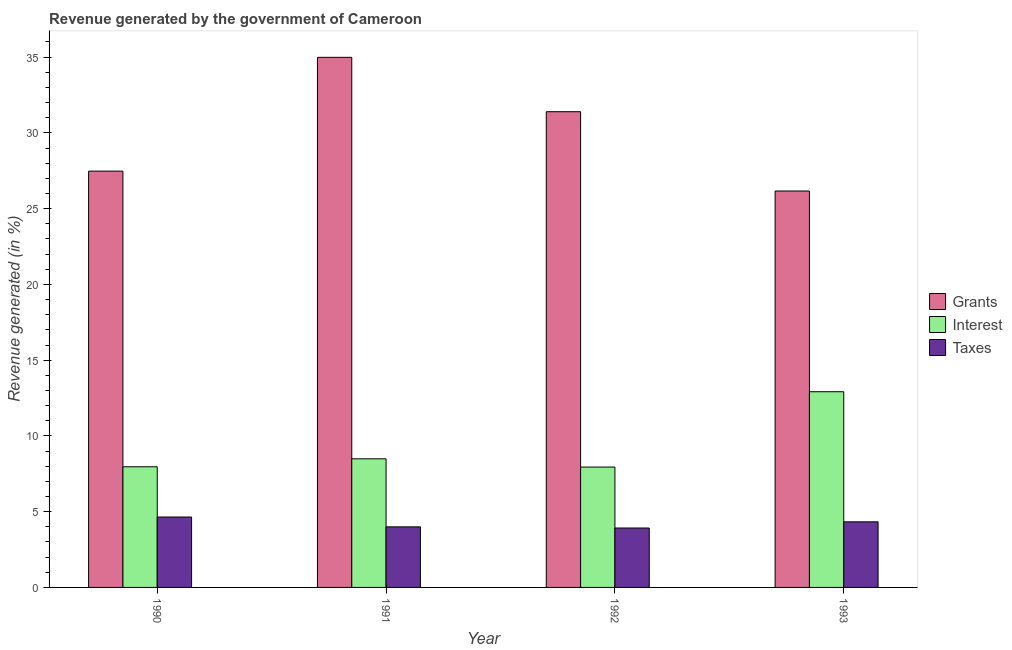Are the number of bars per tick equal to the number of legend labels?
Your answer should be compact. Yes. Are the number of bars on each tick of the X-axis equal?
Provide a succinct answer. Yes. What is the percentage of revenue generated by grants in 1993?
Provide a short and direct response. 26.16. Across all years, what is the maximum percentage of revenue generated by interest?
Your response must be concise. 12.92. Across all years, what is the minimum percentage of revenue generated by interest?
Give a very brief answer. 7.94. In which year was the percentage of revenue generated by grants maximum?
Offer a very short reply. 1991. In which year was the percentage of revenue generated by grants minimum?
Your answer should be very brief. 1993. What is the total percentage of revenue generated by grants in the graph?
Offer a very short reply. 120.02. What is the difference between the percentage of revenue generated by interest in 1991 and that in 1992?
Ensure brevity in your answer.  0.54. What is the difference between the percentage of revenue generated by grants in 1993 and the percentage of revenue generated by taxes in 1991?
Give a very brief answer. -8.82. What is the average percentage of revenue generated by grants per year?
Provide a succinct answer. 30.01. In the year 1993, what is the difference between the percentage of revenue generated by taxes and percentage of revenue generated by interest?
Ensure brevity in your answer.  0. In how many years, is the percentage of revenue generated by interest greater than 22 %?
Give a very brief answer. 0. What is the ratio of the percentage of revenue generated by grants in 1990 to that in 1992?
Give a very brief answer. 0.88. Is the percentage of revenue generated by interest in 1990 less than that in 1992?
Provide a succinct answer. No. Is the difference between the percentage of revenue generated by interest in 1990 and 1993 greater than the difference between the percentage of revenue generated by grants in 1990 and 1993?
Your answer should be compact. No. What is the difference between the highest and the second highest percentage of revenue generated by taxes?
Provide a succinct answer. 0.32. What is the difference between the highest and the lowest percentage of revenue generated by grants?
Your answer should be compact. 8.82. In how many years, is the percentage of revenue generated by taxes greater than the average percentage of revenue generated by taxes taken over all years?
Offer a terse response. 2. Is the sum of the percentage of revenue generated by grants in 1990 and 1991 greater than the maximum percentage of revenue generated by taxes across all years?
Offer a very short reply. Yes. What does the 3rd bar from the left in 1991 represents?
Provide a succinct answer. Taxes. What does the 3rd bar from the right in 1990 represents?
Keep it short and to the point. Grants. Is it the case that in every year, the sum of the percentage of revenue generated by grants and percentage of revenue generated by interest is greater than the percentage of revenue generated by taxes?
Your answer should be compact. Yes. Are all the bars in the graph horizontal?
Give a very brief answer. No. How many years are there in the graph?
Offer a terse response. 4. Are the values on the major ticks of Y-axis written in scientific E-notation?
Your answer should be very brief. No. How are the legend labels stacked?
Your response must be concise. Vertical. What is the title of the graph?
Provide a short and direct response. Revenue generated by the government of Cameroon. What is the label or title of the X-axis?
Your response must be concise. Year. What is the label or title of the Y-axis?
Ensure brevity in your answer.  Revenue generated (in %). What is the Revenue generated (in %) of Grants in 1990?
Offer a terse response. 27.48. What is the Revenue generated (in %) of Interest in 1990?
Your answer should be compact. 7.96. What is the Revenue generated (in %) in Taxes in 1990?
Provide a succinct answer. 4.65. What is the Revenue generated (in %) in Grants in 1991?
Provide a succinct answer. 34.99. What is the Revenue generated (in %) of Interest in 1991?
Make the answer very short. 8.49. What is the Revenue generated (in %) of Taxes in 1991?
Offer a terse response. 4. What is the Revenue generated (in %) in Grants in 1992?
Your answer should be compact. 31.4. What is the Revenue generated (in %) of Interest in 1992?
Ensure brevity in your answer.  7.94. What is the Revenue generated (in %) in Taxes in 1992?
Keep it short and to the point. 3.92. What is the Revenue generated (in %) in Grants in 1993?
Make the answer very short. 26.16. What is the Revenue generated (in %) in Interest in 1993?
Offer a very short reply. 12.92. What is the Revenue generated (in %) in Taxes in 1993?
Your response must be concise. 4.33. Across all years, what is the maximum Revenue generated (in %) of Grants?
Your answer should be compact. 34.99. Across all years, what is the maximum Revenue generated (in %) of Interest?
Your response must be concise. 12.92. Across all years, what is the maximum Revenue generated (in %) of Taxes?
Keep it short and to the point. 4.65. Across all years, what is the minimum Revenue generated (in %) of Grants?
Your answer should be very brief. 26.16. Across all years, what is the minimum Revenue generated (in %) in Interest?
Keep it short and to the point. 7.94. Across all years, what is the minimum Revenue generated (in %) in Taxes?
Your answer should be very brief. 3.92. What is the total Revenue generated (in %) in Grants in the graph?
Your answer should be compact. 120.02. What is the total Revenue generated (in %) of Interest in the graph?
Your response must be concise. 37.31. What is the total Revenue generated (in %) of Taxes in the graph?
Your response must be concise. 16.9. What is the difference between the Revenue generated (in %) of Grants in 1990 and that in 1991?
Provide a succinct answer. -7.51. What is the difference between the Revenue generated (in %) in Interest in 1990 and that in 1991?
Keep it short and to the point. -0.53. What is the difference between the Revenue generated (in %) in Taxes in 1990 and that in 1991?
Keep it short and to the point. 0.65. What is the difference between the Revenue generated (in %) in Grants in 1990 and that in 1992?
Your response must be concise. -3.92. What is the difference between the Revenue generated (in %) in Interest in 1990 and that in 1992?
Provide a short and direct response. 0.02. What is the difference between the Revenue generated (in %) in Taxes in 1990 and that in 1992?
Provide a short and direct response. 0.72. What is the difference between the Revenue generated (in %) of Grants in 1990 and that in 1993?
Offer a terse response. 1.31. What is the difference between the Revenue generated (in %) of Interest in 1990 and that in 1993?
Provide a succinct answer. -4.95. What is the difference between the Revenue generated (in %) of Taxes in 1990 and that in 1993?
Offer a terse response. 0.32. What is the difference between the Revenue generated (in %) of Grants in 1991 and that in 1992?
Provide a short and direct response. 3.59. What is the difference between the Revenue generated (in %) of Interest in 1991 and that in 1992?
Provide a short and direct response. 0.54. What is the difference between the Revenue generated (in %) of Taxes in 1991 and that in 1992?
Provide a succinct answer. 0.08. What is the difference between the Revenue generated (in %) of Grants in 1991 and that in 1993?
Provide a short and direct response. 8.82. What is the difference between the Revenue generated (in %) of Interest in 1991 and that in 1993?
Your response must be concise. -4.43. What is the difference between the Revenue generated (in %) in Taxes in 1991 and that in 1993?
Offer a very short reply. -0.33. What is the difference between the Revenue generated (in %) of Grants in 1992 and that in 1993?
Offer a very short reply. 5.23. What is the difference between the Revenue generated (in %) in Interest in 1992 and that in 1993?
Offer a terse response. -4.97. What is the difference between the Revenue generated (in %) of Taxes in 1992 and that in 1993?
Offer a terse response. -0.41. What is the difference between the Revenue generated (in %) in Grants in 1990 and the Revenue generated (in %) in Interest in 1991?
Your answer should be very brief. 18.99. What is the difference between the Revenue generated (in %) in Grants in 1990 and the Revenue generated (in %) in Taxes in 1991?
Your answer should be very brief. 23.48. What is the difference between the Revenue generated (in %) of Interest in 1990 and the Revenue generated (in %) of Taxes in 1991?
Your answer should be compact. 3.97. What is the difference between the Revenue generated (in %) in Grants in 1990 and the Revenue generated (in %) in Interest in 1992?
Provide a succinct answer. 19.53. What is the difference between the Revenue generated (in %) in Grants in 1990 and the Revenue generated (in %) in Taxes in 1992?
Give a very brief answer. 23.55. What is the difference between the Revenue generated (in %) in Interest in 1990 and the Revenue generated (in %) in Taxes in 1992?
Offer a terse response. 4.04. What is the difference between the Revenue generated (in %) in Grants in 1990 and the Revenue generated (in %) in Interest in 1993?
Your answer should be compact. 14.56. What is the difference between the Revenue generated (in %) of Grants in 1990 and the Revenue generated (in %) of Taxes in 1993?
Your response must be concise. 23.15. What is the difference between the Revenue generated (in %) in Interest in 1990 and the Revenue generated (in %) in Taxes in 1993?
Provide a succinct answer. 3.63. What is the difference between the Revenue generated (in %) in Grants in 1991 and the Revenue generated (in %) in Interest in 1992?
Your answer should be very brief. 27.04. What is the difference between the Revenue generated (in %) in Grants in 1991 and the Revenue generated (in %) in Taxes in 1992?
Your response must be concise. 31.06. What is the difference between the Revenue generated (in %) of Interest in 1991 and the Revenue generated (in %) of Taxes in 1992?
Your response must be concise. 4.57. What is the difference between the Revenue generated (in %) of Grants in 1991 and the Revenue generated (in %) of Interest in 1993?
Ensure brevity in your answer.  22.07. What is the difference between the Revenue generated (in %) of Grants in 1991 and the Revenue generated (in %) of Taxes in 1993?
Provide a succinct answer. 30.66. What is the difference between the Revenue generated (in %) of Interest in 1991 and the Revenue generated (in %) of Taxes in 1993?
Make the answer very short. 4.16. What is the difference between the Revenue generated (in %) of Grants in 1992 and the Revenue generated (in %) of Interest in 1993?
Your answer should be very brief. 18.48. What is the difference between the Revenue generated (in %) of Grants in 1992 and the Revenue generated (in %) of Taxes in 1993?
Make the answer very short. 27.07. What is the difference between the Revenue generated (in %) of Interest in 1992 and the Revenue generated (in %) of Taxes in 1993?
Keep it short and to the point. 3.62. What is the average Revenue generated (in %) in Grants per year?
Ensure brevity in your answer.  30.01. What is the average Revenue generated (in %) in Interest per year?
Offer a very short reply. 9.33. What is the average Revenue generated (in %) of Taxes per year?
Your answer should be very brief. 4.22. In the year 1990, what is the difference between the Revenue generated (in %) of Grants and Revenue generated (in %) of Interest?
Ensure brevity in your answer.  19.51. In the year 1990, what is the difference between the Revenue generated (in %) in Grants and Revenue generated (in %) in Taxes?
Provide a short and direct response. 22.83. In the year 1990, what is the difference between the Revenue generated (in %) in Interest and Revenue generated (in %) in Taxes?
Keep it short and to the point. 3.32. In the year 1991, what is the difference between the Revenue generated (in %) of Grants and Revenue generated (in %) of Interest?
Give a very brief answer. 26.5. In the year 1991, what is the difference between the Revenue generated (in %) of Grants and Revenue generated (in %) of Taxes?
Give a very brief answer. 30.99. In the year 1991, what is the difference between the Revenue generated (in %) of Interest and Revenue generated (in %) of Taxes?
Keep it short and to the point. 4.49. In the year 1992, what is the difference between the Revenue generated (in %) in Grants and Revenue generated (in %) in Interest?
Your answer should be compact. 23.45. In the year 1992, what is the difference between the Revenue generated (in %) of Grants and Revenue generated (in %) of Taxes?
Your answer should be compact. 27.47. In the year 1992, what is the difference between the Revenue generated (in %) of Interest and Revenue generated (in %) of Taxes?
Keep it short and to the point. 4.02. In the year 1993, what is the difference between the Revenue generated (in %) in Grants and Revenue generated (in %) in Interest?
Give a very brief answer. 13.25. In the year 1993, what is the difference between the Revenue generated (in %) of Grants and Revenue generated (in %) of Taxes?
Keep it short and to the point. 21.83. In the year 1993, what is the difference between the Revenue generated (in %) in Interest and Revenue generated (in %) in Taxes?
Provide a short and direct response. 8.59. What is the ratio of the Revenue generated (in %) in Grants in 1990 to that in 1991?
Your answer should be compact. 0.79. What is the ratio of the Revenue generated (in %) of Interest in 1990 to that in 1991?
Ensure brevity in your answer.  0.94. What is the ratio of the Revenue generated (in %) of Taxes in 1990 to that in 1991?
Offer a terse response. 1.16. What is the ratio of the Revenue generated (in %) of Grants in 1990 to that in 1992?
Give a very brief answer. 0.88. What is the ratio of the Revenue generated (in %) of Interest in 1990 to that in 1992?
Make the answer very short. 1. What is the ratio of the Revenue generated (in %) in Taxes in 1990 to that in 1992?
Keep it short and to the point. 1.18. What is the ratio of the Revenue generated (in %) in Grants in 1990 to that in 1993?
Give a very brief answer. 1.05. What is the ratio of the Revenue generated (in %) in Interest in 1990 to that in 1993?
Keep it short and to the point. 0.62. What is the ratio of the Revenue generated (in %) of Taxes in 1990 to that in 1993?
Make the answer very short. 1.07. What is the ratio of the Revenue generated (in %) of Grants in 1991 to that in 1992?
Make the answer very short. 1.11. What is the ratio of the Revenue generated (in %) in Interest in 1991 to that in 1992?
Make the answer very short. 1.07. What is the ratio of the Revenue generated (in %) in Taxes in 1991 to that in 1992?
Make the answer very short. 1.02. What is the ratio of the Revenue generated (in %) in Grants in 1991 to that in 1993?
Provide a short and direct response. 1.34. What is the ratio of the Revenue generated (in %) in Interest in 1991 to that in 1993?
Your response must be concise. 0.66. What is the ratio of the Revenue generated (in %) in Taxes in 1991 to that in 1993?
Provide a short and direct response. 0.92. What is the ratio of the Revenue generated (in %) of Grants in 1992 to that in 1993?
Offer a terse response. 1.2. What is the ratio of the Revenue generated (in %) of Interest in 1992 to that in 1993?
Offer a very short reply. 0.62. What is the ratio of the Revenue generated (in %) of Taxes in 1992 to that in 1993?
Ensure brevity in your answer.  0.91. What is the difference between the highest and the second highest Revenue generated (in %) of Grants?
Ensure brevity in your answer.  3.59. What is the difference between the highest and the second highest Revenue generated (in %) in Interest?
Provide a short and direct response. 4.43. What is the difference between the highest and the second highest Revenue generated (in %) of Taxes?
Offer a terse response. 0.32. What is the difference between the highest and the lowest Revenue generated (in %) in Grants?
Give a very brief answer. 8.82. What is the difference between the highest and the lowest Revenue generated (in %) in Interest?
Provide a succinct answer. 4.97. What is the difference between the highest and the lowest Revenue generated (in %) in Taxes?
Your answer should be compact. 0.72. 